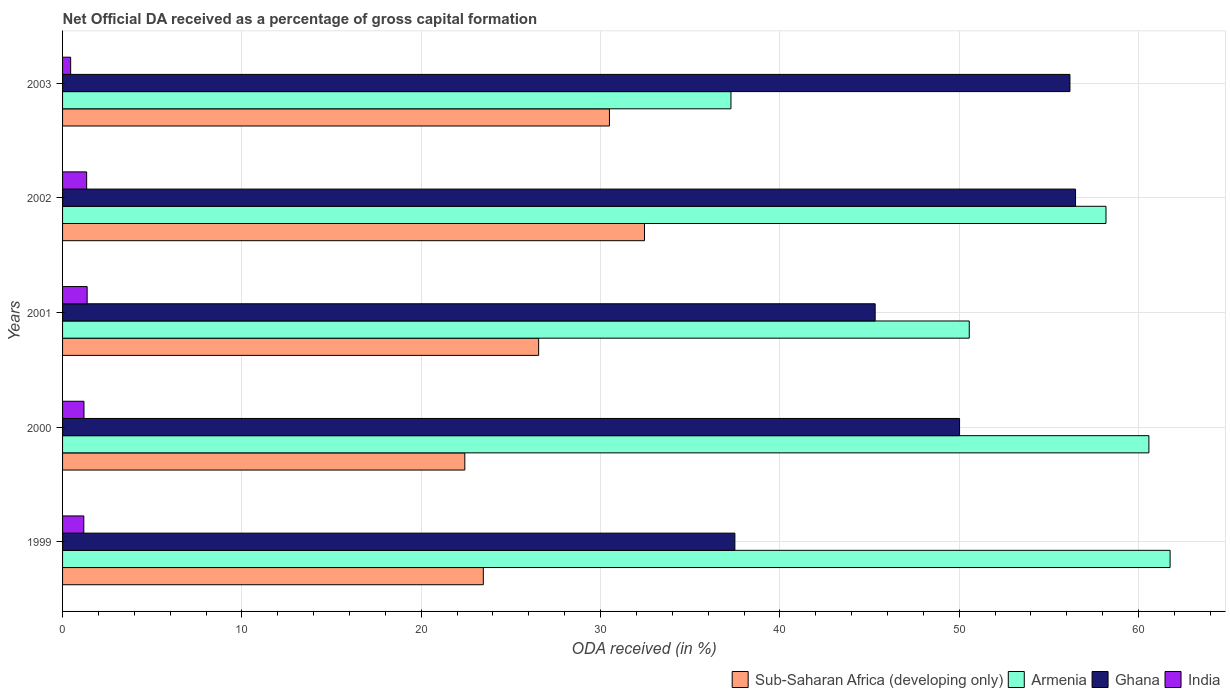How many different coloured bars are there?
Give a very brief answer. 4. Are the number of bars per tick equal to the number of legend labels?
Provide a succinct answer. Yes. What is the label of the 3rd group of bars from the top?
Offer a terse response. 2001. What is the net ODA received in Sub-Saharan Africa (developing only) in 1999?
Offer a terse response. 23.46. Across all years, what is the maximum net ODA received in Sub-Saharan Africa (developing only)?
Provide a short and direct response. 32.45. Across all years, what is the minimum net ODA received in Ghana?
Ensure brevity in your answer.  37.49. In which year was the net ODA received in Sub-Saharan Africa (developing only) maximum?
Provide a succinct answer. 2002. What is the total net ODA received in India in the graph?
Your response must be concise. 5.55. What is the difference between the net ODA received in Ghana in 2001 and that in 2003?
Your answer should be very brief. -10.86. What is the difference between the net ODA received in India in 2001 and the net ODA received in Sub-Saharan Africa (developing only) in 2003?
Provide a short and direct response. -29.12. What is the average net ODA received in Armenia per year?
Offer a terse response. 53.67. In the year 2001, what is the difference between the net ODA received in Armenia and net ODA received in Sub-Saharan Africa (developing only)?
Ensure brevity in your answer.  24.01. In how many years, is the net ODA received in Sub-Saharan Africa (developing only) greater than 12 %?
Keep it short and to the point. 5. What is the ratio of the net ODA received in Ghana in 1999 to that in 2001?
Your response must be concise. 0.83. Is the net ODA received in Ghana in 1999 less than that in 2000?
Keep it short and to the point. Yes. Is the difference between the net ODA received in Armenia in 2001 and 2002 greater than the difference between the net ODA received in Sub-Saharan Africa (developing only) in 2001 and 2002?
Your answer should be compact. No. What is the difference between the highest and the second highest net ODA received in Sub-Saharan Africa (developing only)?
Offer a very short reply. 1.96. What is the difference between the highest and the lowest net ODA received in Sub-Saharan Africa (developing only)?
Offer a very short reply. 10.02. Is the sum of the net ODA received in India in 2000 and 2002 greater than the maximum net ODA received in Armenia across all years?
Ensure brevity in your answer.  No. Is it the case that in every year, the sum of the net ODA received in India and net ODA received in Ghana is greater than the sum of net ODA received in Sub-Saharan Africa (developing only) and net ODA received in Armenia?
Make the answer very short. No. Are the values on the major ticks of X-axis written in scientific E-notation?
Your answer should be very brief. No. How many legend labels are there?
Offer a terse response. 4. How are the legend labels stacked?
Provide a short and direct response. Horizontal. What is the title of the graph?
Give a very brief answer. Net Official DA received as a percentage of gross capital formation. Does "Zambia" appear as one of the legend labels in the graph?
Your answer should be very brief. No. What is the label or title of the X-axis?
Your answer should be very brief. ODA received (in %). What is the ODA received (in %) in Sub-Saharan Africa (developing only) in 1999?
Ensure brevity in your answer.  23.46. What is the ODA received (in %) of Armenia in 1999?
Your answer should be compact. 61.76. What is the ODA received (in %) in Ghana in 1999?
Ensure brevity in your answer.  37.49. What is the ODA received (in %) in India in 1999?
Offer a very short reply. 1.18. What is the ODA received (in %) of Sub-Saharan Africa (developing only) in 2000?
Give a very brief answer. 22.43. What is the ODA received (in %) in Armenia in 2000?
Ensure brevity in your answer.  60.58. What is the ODA received (in %) in Ghana in 2000?
Your answer should be very brief. 50.02. What is the ODA received (in %) in India in 2000?
Make the answer very short. 1.19. What is the ODA received (in %) of Sub-Saharan Africa (developing only) in 2001?
Offer a terse response. 26.55. What is the ODA received (in %) in Armenia in 2001?
Your answer should be very brief. 50.56. What is the ODA received (in %) in Ghana in 2001?
Make the answer very short. 45.31. What is the ODA received (in %) of India in 2001?
Provide a succinct answer. 1.37. What is the ODA received (in %) in Sub-Saharan Africa (developing only) in 2002?
Keep it short and to the point. 32.45. What is the ODA received (in %) of Armenia in 2002?
Give a very brief answer. 58.19. What is the ODA received (in %) of Ghana in 2002?
Provide a short and direct response. 56.49. What is the ODA received (in %) of India in 2002?
Your answer should be compact. 1.34. What is the ODA received (in %) of Sub-Saharan Africa (developing only) in 2003?
Make the answer very short. 30.5. What is the ODA received (in %) of Armenia in 2003?
Keep it short and to the point. 37.27. What is the ODA received (in %) in Ghana in 2003?
Your response must be concise. 56.18. What is the ODA received (in %) of India in 2003?
Your response must be concise. 0.45. Across all years, what is the maximum ODA received (in %) of Sub-Saharan Africa (developing only)?
Provide a succinct answer. 32.45. Across all years, what is the maximum ODA received (in %) of Armenia?
Your answer should be very brief. 61.76. Across all years, what is the maximum ODA received (in %) in Ghana?
Your response must be concise. 56.49. Across all years, what is the maximum ODA received (in %) of India?
Ensure brevity in your answer.  1.37. Across all years, what is the minimum ODA received (in %) in Sub-Saharan Africa (developing only)?
Give a very brief answer. 22.43. Across all years, what is the minimum ODA received (in %) in Armenia?
Your answer should be compact. 37.27. Across all years, what is the minimum ODA received (in %) of Ghana?
Your response must be concise. 37.49. Across all years, what is the minimum ODA received (in %) of India?
Provide a short and direct response. 0.45. What is the total ODA received (in %) of Sub-Saharan Africa (developing only) in the graph?
Your answer should be very brief. 135.39. What is the total ODA received (in %) of Armenia in the graph?
Offer a terse response. 268.36. What is the total ODA received (in %) in Ghana in the graph?
Provide a short and direct response. 245.49. What is the total ODA received (in %) in India in the graph?
Offer a very short reply. 5.55. What is the difference between the ODA received (in %) of Sub-Saharan Africa (developing only) in 1999 and that in 2000?
Ensure brevity in your answer.  1.03. What is the difference between the ODA received (in %) of Armenia in 1999 and that in 2000?
Your response must be concise. 1.18. What is the difference between the ODA received (in %) of Ghana in 1999 and that in 2000?
Your answer should be compact. -12.53. What is the difference between the ODA received (in %) in India in 1999 and that in 2000?
Your answer should be very brief. -0.01. What is the difference between the ODA received (in %) of Sub-Saharan Africa (developing only) in 1999 and that in 2001?
Provide a short and direct response. -3.09. What is the difference between the ODA received (in %) in Armenia in 1999 and that in 2001?
Ensure brevity in your answer.  11.2. What is the difference between the ODA received (in %) in Ghana in 1999 and that in 2001?
Make the answer very short. -7.82. What is the difference between the ODA received (in %) in India in 1999 and that in 2001?
Ensure brevity in your answer.  -0.19. What is the difference between the ODA received (in %) of Sub-Saharan Africa (developing only) in 1999 and that in 2002?
Make the answer very short. -8.99. What is the difference between the ODA received (in %) in Armenia in 1999 and that in 2002?
Make the answer very short. 3.58. What is the difference between the ODA received (in %) of Ghana in 1999 and that in 2002?
Ensure brevity in your answer.  -19. What is the difference between the ODA received (in %) of India in 1999 and that in 2002?
Provide a succinct answer. -0.16. What is the difference between the ODA received (in %) of Sub-Saharan Africa (developing only) in 1999 and that in 2003?
Your answer should be compact. -7.03. What is the difference between the ODA received (in %) in Armenia in 1999 and that in 2003?
Ensure brevity in your answer.  24.49. What is the difference between the ODA received (in %) of Ghana in 1999 and that in 2003?
Your response must be concise. -18.68. What is the difference between the ODA received (in %) in India in 1999 and that in 2003?
Provide a succinct answer. 0.73. What is the difference between the ODA received (in %) in Sub-Saharan Africa (developing only) in 2000 and that in 2001?
Offer a terse response. -4.12. What is the difference between the ODA received (in %) in Armenia in 2000 and that in 2001?
Your answer should be very brief. 10.02. What is the difference between the ODA received (in %) in Ghana in 2000 and that in 2001?
Make the answer very short. 4.71. What is the difference between the ODA received (in %) of India in 2000 and that in 2001?
Provide a succinct answer. -0.18. What is the difference between the ODA received (in %) of Sub-Saharan Africa (developing only) in 2000 and that in 2002?
Provide a succinct answer. -10.02. What is the difference between the ODA received (in %) in Armenia in 2000 and that in 2002?
Your response must be concise. 2.39. What is the difference between the ODA received (in %) in Ghana in 2000 and that in 2002?
Provide a short and direct response. -6.47. What is the difference between the ODA received (in %) of India in 2000 and that in 2002?
Offer a very short reply. -0.15. What is the difference between the ODA received (in %) in Sub-Saharan Africa (developing only) in 2000 and that in 2003?
Your response must be concise. -8.06. What is the difference between the ODA received (in %) of Armenia in 2000 and that in 2003?
Give a very brief answer. 23.31. What is the difference between the ODA received (in %) of Ghana in 2000 and that in 2003?
Give a very brief answer. -6.16. What is the difference between the ODA received (in %) of India in 2000 and that in 2003?
Keep it short and to the point. 0.74. What is the difference between the ODA received (in %) in Sub-Saharan Africa (developing only) in 2001 and that in 2002?
Keep it short and to the point. -5.9. What is the difference between the ODA received (in %) in Armenia in 2001 and that in 2002?
Make the answer very short. -7.63. What is the difference between the ODA received (in %) in Ghana in 2001 and that in 2002?
Provide a short and direct response. -11.17. What is the difference between the ODA received (in %) of India in 2001 and that in 2002?
Make the answer very short. 0.03. What is the difference between the ODA received (in %) of Sub-Saharan Africa (developing only) in 2001 and that in 2003?
Your answer should be very brief. -3.95. What is the difference between the ODA received (in %) of Armenia in 2001 and that in 2003?
Provide a short and direct response. 13.29. What is the difference between the ODA received (in %) of Ghana in 2001 and that in 2003?
Provide a short and direct response. -10.86. What is the difference between the ODA received (in %) in India in 2001 and that in 2003?
Provide a short and direct response. 0.92. What is the difference between the ODA received (in %) in Sub-Saharan Africa (developing only) in 2002 and that in 2003?
Make the answer very short. 1.96. What is the difference between the ODA received (in %) of Armenia in 2002 and that in 2003?
Keep it short and to the point. 20.91. What is the difference between the ODA received (in %) of Ghana in 2002 and that in 2003?
Offer a terse response. 0.31. What is the difference between the ODA received (in %) in India in 2002 and that in 2003?
Your answer should be compact. 0.89. What is the difference between the ODA received (in %) of Sub-Saharan Africa (developing only) in 1999 and the ODA received (in %) of Armenia in 2000?
Give a very brief answer. -37.12. What is the difference between the ODA received (in %) of Sub-Saharan Africa (developing only) in 1999 and the ODA received (in %) of Ghana in 2000?
Provide a short and direct response. -26.56. What is the difference between the ODA received (in %) of Sub-Saharan Africa (developing only) in 1999 and the ODA received (in %) of India in 2000?
Your answer should be very brief. 22.27. What is the difference between the ODA received (in %) of Armenia in 1999 and the ODA received (in %) of Ghana in 2000?
Your response must be concise. 11.74. What is the difference between the ODA received (in %) of Armenia in 1999 and the ODA received (in %) of India in 2000?
Make the answer very short. 60.57. What is the difference between the ODA received (in %) in Ghana in 1999 and the ODA received (in %) in India in 2000?
Give a very brief answer. 36.3. What is the difference between the ODA received (in %) of Sub-Saharan Africa (developing only) in 1999 and the ODA received (in %) of Armenia in 2001?
Ensure brevity in your answer.  -27.1. What is the difference between the ODA received (in %) of Sub-Saharan Africa (developing only) in 1999 and the ODA received (in %) of Ghana in 2001?
Offer a very short reply. -21.85. What is the difference between the ODA received (in %) of Sub-Saharan Africa (developing only) in 1999 and the ODA received (in %) of India in 2001?
Ensure brevity in your answer.  22.09. What is the difference between the ODA received (in %) in Armenia in 1999 and the ODA received (in %) in Ghana in 2001?
Make the answer very short. 16.45. What is the difference between the ODA received (in %) of Armenia in 1999 and the ODA received (in %) of India in 2001?
Provide a succinct answer. 60.39. What is the difference between the ODA received (in %) in Ghana in 1999 and the ODA received (in %) in India in 2001?
Your answer should be compact. 36.12. What is the difference between the ODA received (in %) of Sub-Saharan Africa (developing only) in 1999 and the ODA received (in %) of Armenia in 2002?
Your answer should be very brief. -34.72. What is the difference between the ODA received (in %) in Sub-Saharan Africa (developing only) in 1999 and the ODA received (in %) in Ghana in 2002?
Offer a terse response. -33.03. What is the difference between the ODA received (in %) of Sub-Saharan Africa (developing only) in 1999 and the ODA received (in %) of India in 2002?
Offer a terse response. 22.12. What is the difference between the ODA received (in %) in Armenia in 1999 and the ODA received (in %) in Ghana in 2002?
Your response must be concise. 5.27. What is the difference between the ODA received (in %) of Armenia in 1999 and the ODA received (in %) of India in 2002?
Your answer should be compact. 60.42. What is the difference between the ODA received (in %) in Ghana in 1999 and the ODA received (in %) in India in 2002?
Ensure brevity in your answer.  36.15. What is the difference between the ODA received (in %) of Sub-Saharan Africa (developing only) in 1999 and the ODA received (in %) of Armenia in 2003?
Keep it short and to the point. -13.81. What is the difference between the ODA received (in %) of Sub-Saharan Africa (developing only) in 1999 and the ODA received (in %) of Ghana in 2003?
Your answer should be compact. -32.71. What is the difference between the ODA received (in %) of Sub-Saharan Africa (developing only) in 1999 and the ODA received (in %) of India in 2003?
Provide a short and direct response. 23.01. What is the difference between the ODA received (in %) of Armenia in 1999 and the ODA received (in %) of Ghana in 2003?
Provide a short and direct response. 5.59. What is the difference between the ODA received (in %) of Armenia in 1999 and the ODA received (in %) of India in 2003?
Offer a terse response. 61.31. What is the difference between the ODA received (in %) in Ghana in 1999 and the ODA received (in %) in India in 2003?
Offer a terse response. 37.04. What is the difference between the ODA received (in %) in Sub-Saharan Africa (developing only) in 2000 and the ODA received (in %) in Armenia in 2001?
Your answer should be compact. -28.13. What is the difference between the ODA received (in %) in Sub-Saharan Africa (developing only) in 2000 and the ODA received (in %) in Ghana in 2001?
Make the answer very short. -22.88. What is the difference between the ODA received (in %) in Sub-Saharan Africa (developing only) in 2000 and the ODA received (in %) in India in 2001?
Give a very brief answer. 21.06. What is the difference between the ODA received (in %) of Armenia in 2000 and the ODA received (in %) of Ghana in 2001?
Offer a terse response. 15.26. What is the difference between the ODA received (in %) in Armenia in 2000 and the ODA received (in %) in India in 2001?
Your answer should be very brief. 59.21. What is the difference between the ODA received (in %) of Ghana in 2000 and the ODA received (in %) of India in 2001?
Your answer should be compact. 48.65. What is the difference between the ODA received (in %) in Sub-Saharan Africa (developing only) in 2000 and the ODA received (in %) in Armenia in 2002?
Your answer should be compact. -35.76. What is the difference between the ODA received (in %) in Sub-Saharan Africa (developing only) in 2000 and the ODA received (in %) in Ghana in 2002?
Offer a terse response. -34.06. What is the difference between the ODA received (in %) in Sub-Saharan Africa (developing only) in 2000 and the ODA received (in %) in India in 2002?
Your answer should be very brief. 21.09. What is the difference between the ODA received (in %) in Armenia in 2000 and the ODA received (in %) in Ghana in 2002?
Ensure brevity in your answer.  4.09. What is the difference between the ODA received (in %) in Armenia in 2000 and the ODA received (in %) in India in 2002?
Provide a succinct answer. 59.23. What is the difference between the ODA received (in %) in Ghana in 2000 and the ODA received (in %) in India in 2002?
Make the answer very short. 48.68. What is the difference between the ODA received (in %) of Sub-Saharan Africa (developing only) in 2000 and the ODA received (in %) of Armenia in 2003?
Make the answer very short. -14.84. What is the difference between the ODA received (in %) of Sub-Saharan Africa (developing only) in 2000 and the ODA received (in %) of Ghana in 2003?
Ensure brevity in your answer.  -33.75. What is the difference between the ODA received (in %) in Sub-Saharan Africa (developing only) in 2000 and the ODA received (in %) in India in 2003?
Provide a short and direct response. 21.98. What is the difference between the ODA received (in %) in Armenia in 2000 and the ODA received (in %) in Ghana in 2003?
Offer a terse response. 4.4. What is the difference between the ODA received (in %) in Armenia in 2000 and the ODA received (in %) in India in 2003?
Offer a very short reply. 60.13. What is the difference between the ODA received (in %) in Ghana in 2000 and the ODA received (in %) in India in 2003?
Offer a terse response. 49.57. What is the difference between the ODA received (in %) of Sub-Saharan Africa (developing only) in 2001 and the ODA received (in %) of Armenia in 2002?
Ensure brevity in your answer.  -31.64. What is the difference between the ODA received (in %) in Sub-Saharan Africa (developing only) in 2001 and the ODA received (in %) in Ghana in 2002?
Make the answer very short. -29.94. What is the difference between the ODA received (in %) in Sub-Saharan Africa (developing only) in 2001 and the ODA received (in %) in India in 2002?
Give a very brief answer. 25.2. What is the difference between the ODA received (in %) in Armenia in 2001 and the ODA received (in %) in Ghana in 2002?
Make the answer very short. -5.93. What is the difference between the ODA received (in %) in Armenia in 2001 and the ODA received (in %) in India in 2002?
Keep it short and to the point. 49.22. What is the difference between the ODA received (in %) in Ghana in 2001 and the ODA received (in %) in India in 2002?
Your answer should be compact. 43.97. What is the difference between the ODA received (in %) of Sub-Saharan Africa (developing only) in 2001 and the ODA received (in %) of Armenia in 2003?
Your answer should be compact. -10.72. What is the difference between the ODA received (in %) in Sub-Saharan Africa (developing only) in 2001 and the ODA received (in %) in Ghana in 2003?
Provide a short and direct response. -29.63. What is the difference between the ODA received (in %) of Sub-Saharan Africa (developing only) in 2001 and the ODA received (in %) of India in 2003?
Your answer should be very brief. 26.1. What is the difference between the ODA received (in %) in Armenia in 2001 and the ODA received (in %) in Ghana in 2003?
Offer a very short reply. -5.62. What is the difference between the ODA received (in %) in Armenia in 2001 and the ODA received (in %) in India in 2003?
Give a very brief answer. 50.11. What is the difference between the ODA received (in %) of Ghana in 2001 and the ODA received (in %) of India in 2003?
Make the answer very short. 44.86. What is the difference between the ODA received (in %) of Sub-Saharan Africa (developing only) in 2002 and the ODA received (in %) of Armenia in 2003?
Your answer should be very brief. -4.82. What is the difference between the ODA received (in %) of Sub-Saharan Africa (developing only) in 2002 and the ODA received (in %) of Ghana in 2003?
Keep it short and to the point. -23.73. What is the difference between the ODA received (in %) in Sub-Saharan Africa (developing only) in 2002 and the ODA received (in %) in India in 2003?
Provide a short and direct response. 32. What is the difference between the ODA received (in %) in Armenia in 2002 and the ODA received (in %) in Ghana in 2003?
Offer a terse response. 2.01. What is the difference between the ODA received (in %) in Armenia in 2002 and the ODA received (in %) in India in 2003?
Your answer should be compact. 57.73. What is the difference between the ODA received (in %) of Ghana in 2002 and the ODA received (in %) of India in 2003?
Give a very brief answer. 56.04. What is the average ODA received (in %) of Sub-Saharan Africa (developing only) per year?
Give a very brief answer. 27.08. What is the average ODA received (in %) in Armenia per year?
Your response must be concise. 53.67. What is the average ODA received (in %) in Ghana per year?
Make the answer very short. 49.1. What is the average ODA received (in %) in India per year?
Offer a terse response. 1.11. In the year 1999, what is the difference between the ODA received (in %) of Sub-Saharan Africa (developing only) and ODA received (in %) of Armenia?
Ensure brevity in your answer.  -38.3. In the year 1999, what is the difference between the ODA received (in %) in Sub-Saharan Africa (developing only) and ODA received (in %) in Ghana?
Give a very brief answer. -14.03. In the year 1999, what is the difference between the ODA received (in %) of Sub-Saharan Africa (developing only) and ODA received (in %) of India?
Provide a short and direct response. 22.28. In the year 1999, what is the difference between the ODA received (in %) in Armenia and ODA received (in %) in Ghana?
Keep it short and to the point. 24.27. In the year 1999, what is the difference between the ODA received (in %) in Armenia and ODA received (in %) in India?
Offer a terse response. 60.58. In the year 1999, what is the difference between the ODA received (in %) of Ghana and ODA received (in %) of India?
Offer a very short reply. 36.31. In the year 2000, what is the difference between the ODA received (in %) in Sub-Saharan Africa (developing only) and ODA received (in %) in Armenia?
Keep it short and to the point. -38.15. In the year 2000, what is the difference between the ODA received (in %) in Sub-Saharan Africa (developing only) and ODA received (in %) in Ghana?
Ensure brevity in your answer.  -27.59. In the year 2000, what is the difference between the ODA received (in %) in Sub-Saharan Africa (developing only) and ODA received (in %) in India?
Give a very brief answer. 21.24. In the year 2000, what is the difference between the ODA received (in %) of Armenia and ODA received (in %) of Ghana?
Give a very brief answer. 10.56. In the year 2000, what is the difference between the ODA received (in %) in Armenia and ODA received (in %) in India?
Ensure brevity in your answer.  59.38. In the year 2000, what is the difference between the ODA received (in %) of Ghana and ODA received (in %) of India?
Give a very brief answer. 48.83. In the year 2001, what is the difference between the ODA received (in %) of Sub-Saharan Africa (developing only) and ODA received (in %) of Armenia?
Keep it short and to the point. -24.01. In the year 2001, what is the difference between the ODA received (in %) of Sub-Saharan Africa (developing only) and ODA received (in %) of Ghana?
Provide a short and direct response. -18.77. In the year 2001, what is the difference between the ODA received (in %) in Sub-Saharan Africa (developing only) and ODA received (in %) in India?
Offer a terse response. 25.18. In the year 2001, what is the difference between the ODA received (in %) in Armenia and ODA received (in %) in Ghana?
Keep it short and to the point. 5.25. In the year 2001, what is the difference between the ODA received (in %) of Armenia and ODA received (in %) of India?
Offer a terse response. 49.19. In the year 2001, what is the difference between the ODA received (in %) of Ghana and ODA received (in %) of India?
Your answer should be very brief. 43.94. In the year 2002, what is the difference between the ODA received (in %) of Sub-Saharan Africa (developing only) and ODA received (in %) of Armenia?
Your response must be concise. -25.73. In the year 2002, what is the difference between the ODA received (in %) of Sub-Saharan Africa (developing only) and ODA received (in %) of Ghana?
Offer a very short reply. -24.04. In the year 2002, what is the difference between the ODA received (in %) in Sub-Saharan Africa (developing only) and ODA received (in %) in India?
Your answer should be very brief. 31.11. In the year 2002, what is the difference between the ODA received (in %) in Armenia and ODA received (in %) in Ghana?
Keep it short and to the point. 1.7. In the year 2002, what is the difference between the ODA received (in %) of Armenia and ODA received (in %) of India?
Your answer should be very brief. 56.84. In the year 2002, what is the difference between the ODA received (in %) of Ghana and ODA received (in %) of India?
Offer a terse response. 55.14. In the year 2003, what is the difference between the ODA received (in %) in Sub-Saharan Africa (developing only) and ODA received (in %) in Armenia?
Your answer should be compact. -6.78. In the year 2003, what is the difference between the ODA received (in %) of Sub-Saharan Africa (developing only) and ODA received (in %) of Ghana?
Offer a very short reply. -25.68. In the year 2003, what is the difference between the ODA received (in %) of Sub-Saharan Africa (developing only) and ODA received (in %) of India?
Provide a succinct answer. 30.04. In the year 2003, what is the difference between the ODA received (in %) in Armenia and ODA received (in %) in Ghana?
Your answer should be compact. -18.9. In the year 2003, what is the difference between the ODA received (in %) of Armenia and ODA received (in %) of India?
Provide a short and direct response. 36.82. In the year 2003, what is the difference between the ODA received (in %) in Ghana and ODA received (in %) in India?
Your answer should be very brief. 55.73. What is the ratio of the ODA received (in %) of Sub-Saharan Africa (developing only) in 1999 to that in 2000?
Keep it short and to the point. 1.05. What is the ratio of the ODA received (in %) of Armenia in 1999 to that in 2000?
Give a very brief answer. 1.02. What is the ratio of the ODA received (in %) of Ghana in 1999 to that in 2000?
Provide a short and direct response. 0.75. What is the ratio of the ODA received (in %) in India in 1999 to that in 2000?
Provide a succinct answer. 0.99. What is the ratio of the ODA received (in %) of Sub-Saharan Africa (developing only) in 1999 to that in 2001?
Provide a short and direct response. 0.88. What is the ratio of the ODA received (in %) in Armenia in 1999 to that in 2001?
Your answer should be compact. 1.22. What is the ratio of the ODA received (in %) in Ghana in 1999 to that in 2001?
Offer a very short reply. 0.83. What is the ratio of the ODA received (in %) of India in 1999 to that in 2001?
Offer a terse response. 0.86. What is the ratio of the ODA received (in %) in Sub-Saharan Africa (developing only) in 1999 to that in 2002?
Make the answer very short. 0.72. What is the ratio of the ODA received (in %) of Armenia in 1999 to that in 2002?
Ensure brevity in your answer.  1.06. What is the ratio of the ODA received (in %) in Ghana in 1999 to that in 2002?
Keep it short and to the point. 0.66. What is the ratio of the ODA received (in %) of India in 1999 to that in 2002?
Keep it short and to the point. 0.88. What is the ratio of the ODA received (in %) in Sub-Saharan Africa (developing only) in 1999 to that in 2003?
Give a very brief answer. 0.77. What is the ratio of the ODA received (in %) in Armenia in 1999 to that in 2003?
Your answer should be very brief. 1.66. What is the ratio of the ODA received (in %) in Ghana in 1999 to that in 2003?
Keep it short and to the point. 0.67. What is the ratio of the ODA received (in %) of India in 1999 to that in 2003?
Give a very brief answer. 2.62. What is the ratio of the ODA received (in %) of Sub-Saharan Africa (developing only) in 2000 to that in 2001?
Your response must be concise. 0.84. What is the ratio of the ODA received (in %) in Armenia in 2000 to that in 2001?
Your answer should be very brief. 1.2. What is the ratio of the ODA received (in %) of Ghana in 2000 to that in 2001?
Your answer should be very brief. 1.1. What is the ratio of the ODA received (in %) in India in 2000 to that in 2001?
Offer a very short reply. 0.87. What is the ratio of the ODA received (in %) in Sub-Saharan Africa (developing only) in 2000 to that in 2002?
Your response must be concise. 0.69. What is the ratio of the ODA received (in %) of Armenia in 2000 to that in 2002?
Ensure brevity in your answer.  1.04. What is the ratio of the ODA received (in %) of Ghana in 2000 to that in 2002?
Offer a very short reply. 0.89. What is the ratio of the ODA received (in %) of India in 2000 to that in 2002?
Offer a terse response. 0.89. What is the ratio of the ODA received (in %) in Sub-Saharan Africa (developing only) in 2000 to that in 2003?
Offer a terse response. 0.74. What is the ratio of the ODA received (in %) of Armenia in 2000 to that in 2003?
Your response must be concise. 1.63. What is the ratio of the ODA received (in %) of Ghana in 2000 to that in 2003?
Your response must be concise. 0.89. What is the ratio of the ODA received (in %) of India in 2000 to that in 2003?
Keep it short and to the point. 2.65. What is the ratio of the ODA received (in %) in Sub-Saharan Africa (developing only) in 2001 to that in 2002?
Offer a terse response. 0.82. What is the ratio of the ODA received (in %) of Armenia in 2001 to that in 2002?
Provide a succinct answer. 0.87. What is the ratio of the ODA received (in %) of Ghana in 2001 to that in 2002?
Your answer should be compact. 0.8. What is the ratio of the ODA received (in %) in India in 2001 to that in 2002?
Your answer should be very brief. 1.02. What is the ratio of the ODA received (in %) in Sub-Saharan Africa (developing only) in 2001 to that in 2003?
Provide a succinct answer. 0.87. What is the ratio of the ODA received (in %) in Armenia in 2001 to that in 2003?
Keep it short and to the point. 1.36. What is the ratio of the ODA received (in %) in Ghana in 2001 to that in 2003?
Ensure brevity in your answer.  0.81. What is the ratio of the ODA received (in %) of India in 2001 to that in 2003?
Your response must be concise. 3.04. What is the ratio of the ODA received (in %) in Sub-Saharan Africa (developing only) in 2002 to that in 2003?
Offer a very short reply. 1.06. What is the ratio of the ODA received (in %) in Armenia in 2002 to that in 2003?
Your answer should be very brief. 1.56. What is the ratio of the ODA received (in %) of India in 2002 to that in 2003?
Give a very brief answer. 2.98. What is the difference between the highest and the second highest ODA received (in %) in Sub-Saharan Africa (developing only)?
Give a very brief answer. 1.96. What is the difference between the highest and the second highest ODA received (in %) of Armenia?
Offer a terse response. 1.18. What is the difference between the highest and the second highest ODA received (in %) of Ghana?
Your response must be concise. 0.31. What is the difference between the highest and the second highest ODA received (in %) of India?
Your answer should be very brief. 0.03. What is the difference between the highest and the lowest ODA received (in %) of Sub-Saharan Africa (developing only)?
Keep it short and to the point. 10.02. What is the difference between the highest and the lowest ODA received (in %) in Armenia?
Give a very brief answer. 24.49. What is the difference between the highest and the lowest ODA received (in %) in Ghana?
Give a very brief answer. 19. What is the difference between the highest and the lowest ODA received (in %) in India?
Make the answer very short. 0.92. 